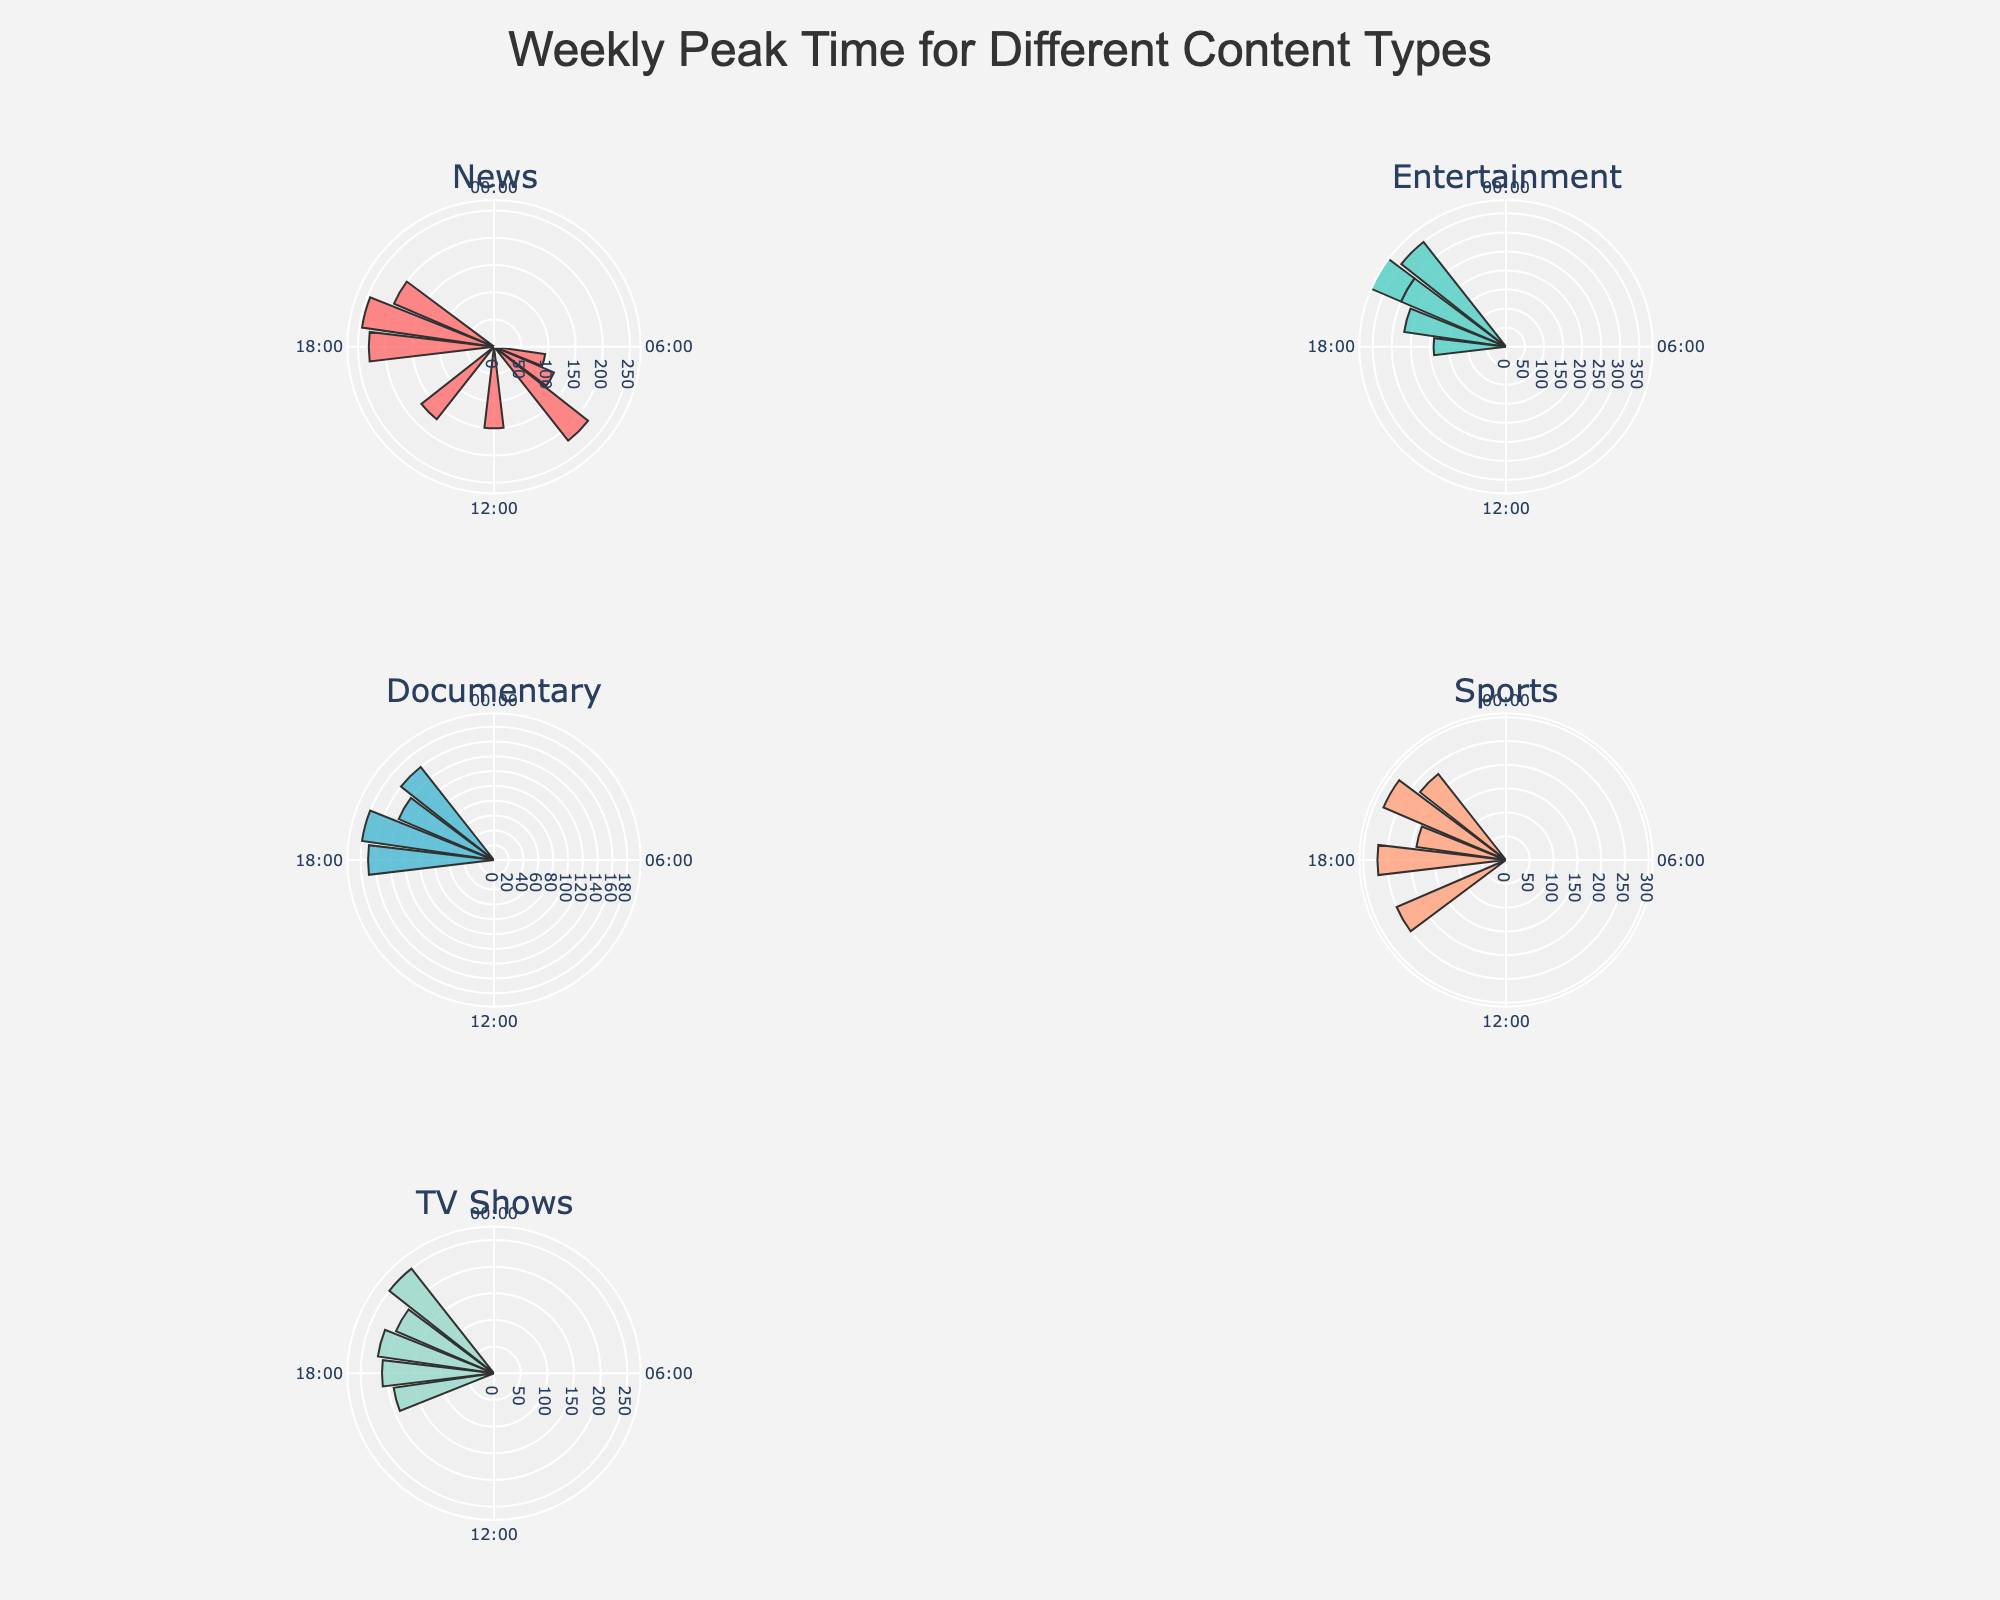What is the title of the figure? The title is typically located at the top of the figure. In this case, it should be easily readable.
Answer: "Weekly Peak Time for Different Content Types" Which content type has the highest peak count, and what is that count? By examining each subplot, you can identify the maximum count for each content type. The highest peak count is in the "Entertainment" content type on Saturday at 21:00.
Answer: Entertainment, 350 During which hour does "News" have its highest peak time on Sunday? Look at the polar subplot for "News" and find the bar that corresponds to Sunday. Check the hour value indicated for this bar.
Answer: 15:00 Compare the peak times for "Sports" and "TV Shows" on Sunday. What is the difference in their peak hour values? Locate the bars for "Sports" and "TV Shows" on Sunday in their respective subplots. The peak hours for both content types can then be subtracted to find the difference.
Answer: 18:00 - 19:00 = -1 hour Which content type shows the highest count on Wednesday, and what is the count? Examine the subplots for each content type focusing on Wednesday. Identify the highest count among them.
Answer: News, 245 What is the average count for "Documentary" content type based on the given data points? Sum the counts for "Documentary" and divide by the number of data points for "Documentary". There are 4 counts: (160 + 180 + 140 + 170) / 4.
Answer: 162.5 How do the peak times for "Entertainment" differ on Friday and Saturday? Compare the bars for "Entertainment" on Friday and Saturday in the respective subplot. Identify the hour values for these bars and their count.
Answer: Friday (20:00) - 300, Saturday (21:00) - 350 Which day has the most frequent peak time occurrence across all content types? Count the number of peak times for each day across all content types, and identify the day with the highest number of occurrences.
Answer: Saturday What range of counts do the "Sports" content type display on Saturday? Look at the polar subplot for "Sports" and identify the minimum and maximum counts for Saturday.
Answer: 250 - 280 